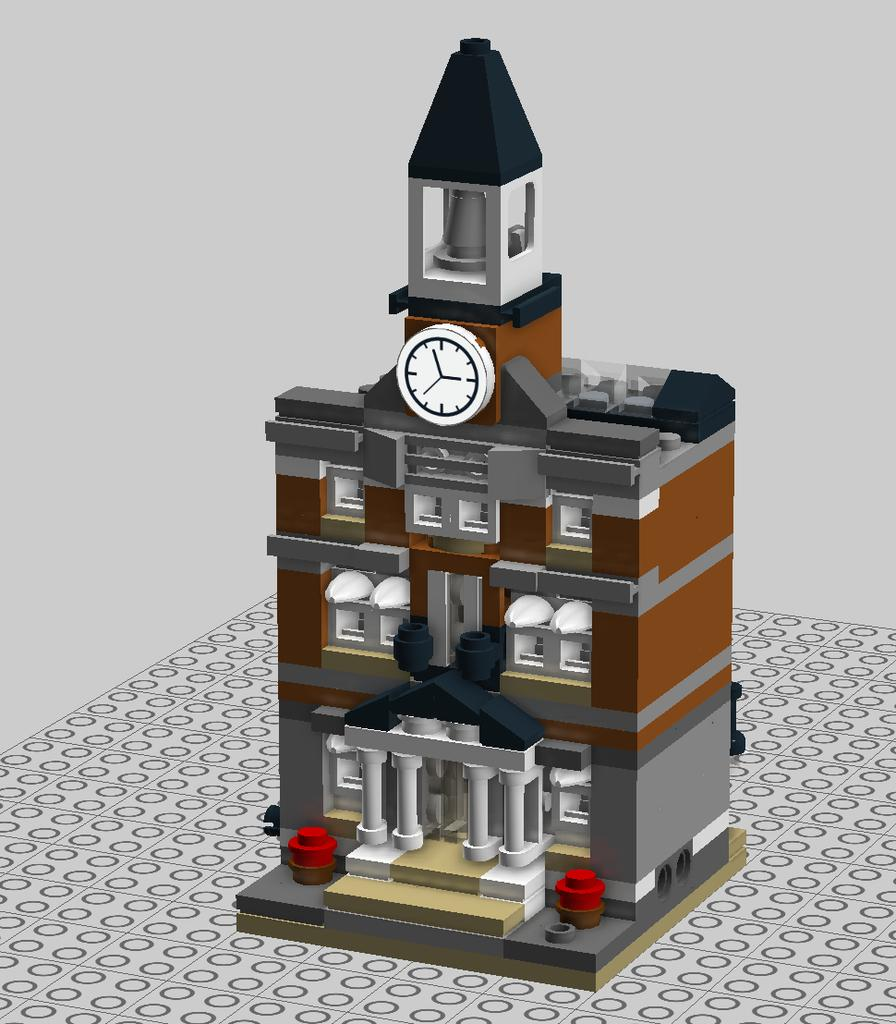What type of image is being described? The image is animated. What object can be seen in the image? There is a toy building in the image. Where is the toy building located? The toy building is placed on the floor. What color is the background of the image? The background of the image is white. Can you see a rainstorm happening in the background of the image? No, there is no rainstorm present in the image. The background is white, and the focus is on the toy building on the floor. 